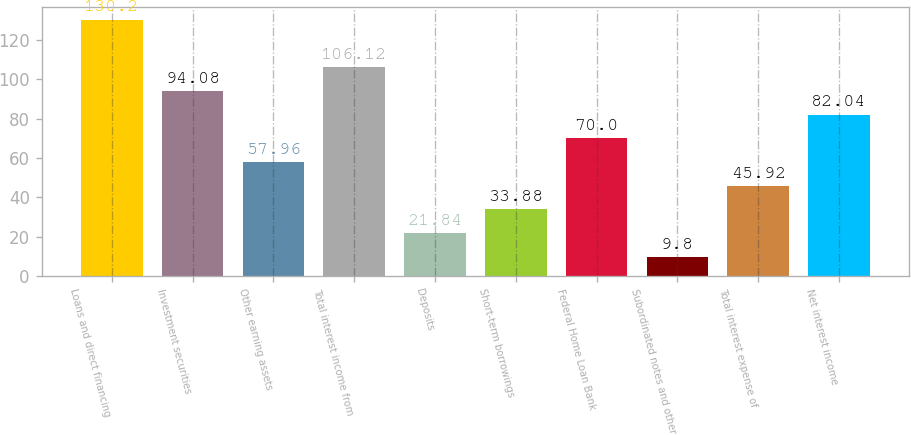<chart> <loc_0><loc_0><loc_500><loc_500><bar_chart><fcel>Loans and direct financing<fcel>Investment securities<fcel>Other earning assets<fcel>Total interest income from<fcel>Deposits<fcel>Short-term borrowings<fcel>Federal Home Loan Bank<fcel>Subordinated notes and other<fcel>Total interest expense of<fcel>Net interest income<nl><fcel>130.2<fcel>94.08<fcel>57.96<fcel>106.12<fcel>21.84<fcel>33.88<fcel>70<fcel>9.8<fcel>45.92<fcel>82.04<nl></chart> 